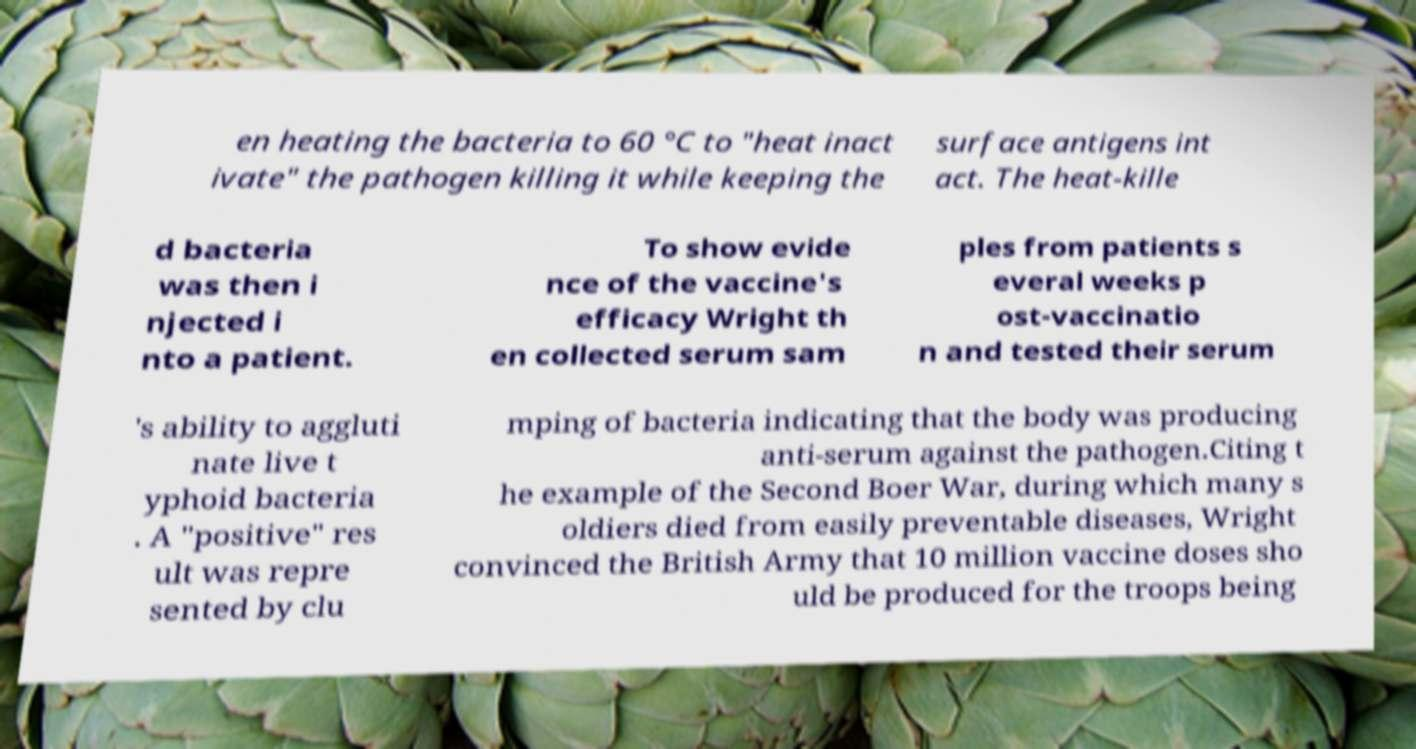Please identify and transcribe the text found in this image. en heating the bacteria to 60 °C to "heat inact ivate" the pathogen killing it while keeping the surface antigens int act. The heat-kille d bacteria was then i njected i nto a patient. To show evide nce of the vaccine's efficacy Wright th en collected serum sam ples from patients s everal weeks p ost-vaccinatio n and tested their serum 's ability to aggluti nate live t yphoid bacteria . A "positive" res ult was repre sented by clu mping of bacteria indicating that the body was producing anti-serum against the pathogen.Citing t he example of the Second Boer War, during which many s oldiers died from easily preventable diseases, Wright convinced the British Army that 10 million vaccine doses sho uld be produced for the troops being 